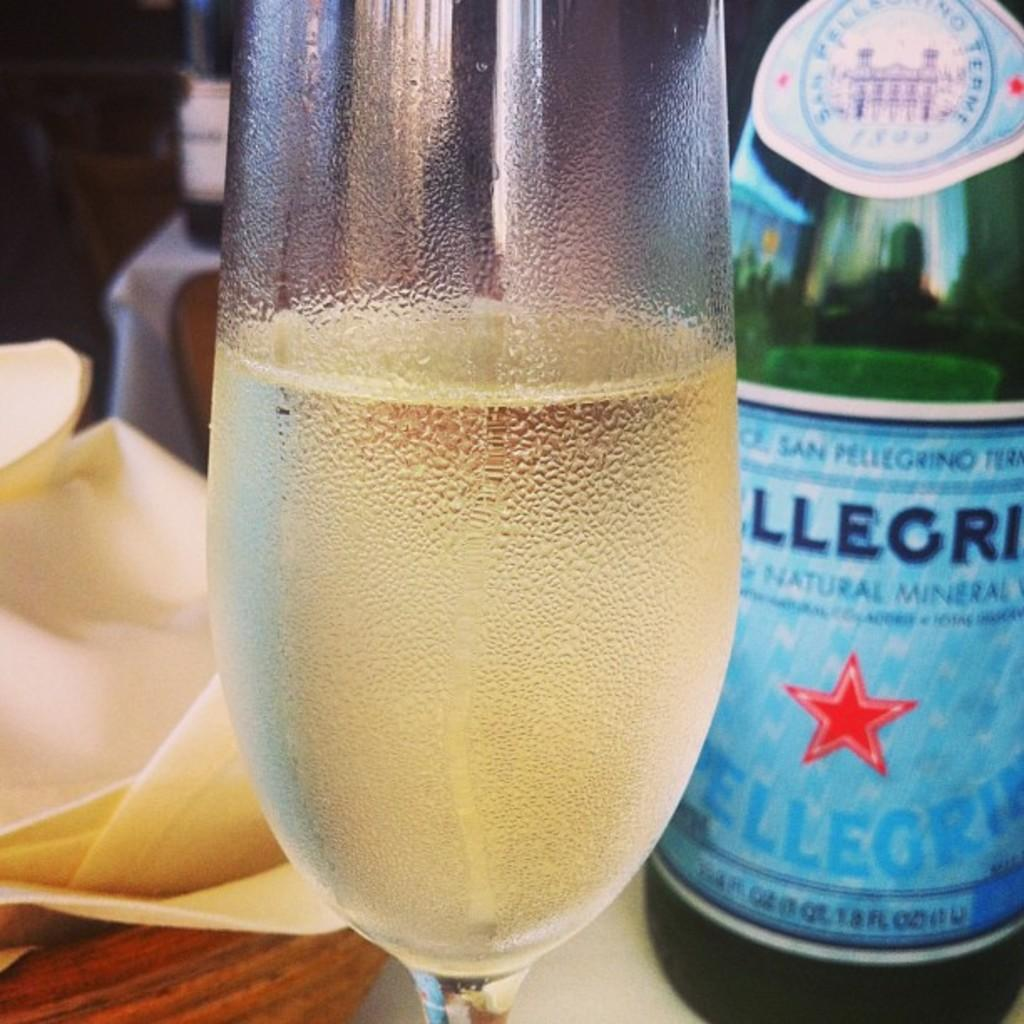<image>
Render a clear and concise summary of the photo. A cool and frosty glass of Pellegrino is standing next to the bottle. 